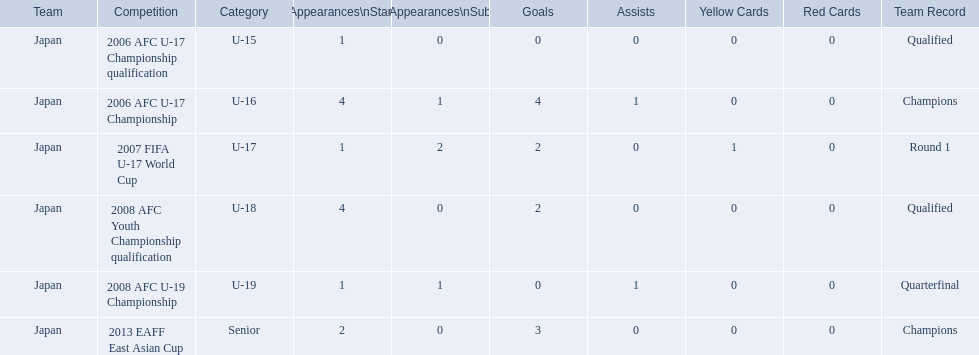How many appearances were there for each competition? 1, 4, 1, 4, 1, 2. How many goals were there for each competition? 0, 4, 2, 2, 0, 3. Which competition(s) has/have the most appearances? 2006 AFC U-17 Championship, 2008 AFC Youth Championship qualification. Which competition(s) has/have the most goals? 2006 AFC U-17 Championship. 